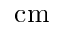<formula> <loc_0><loc_0><loc_500><loc_500>c m</formula> 